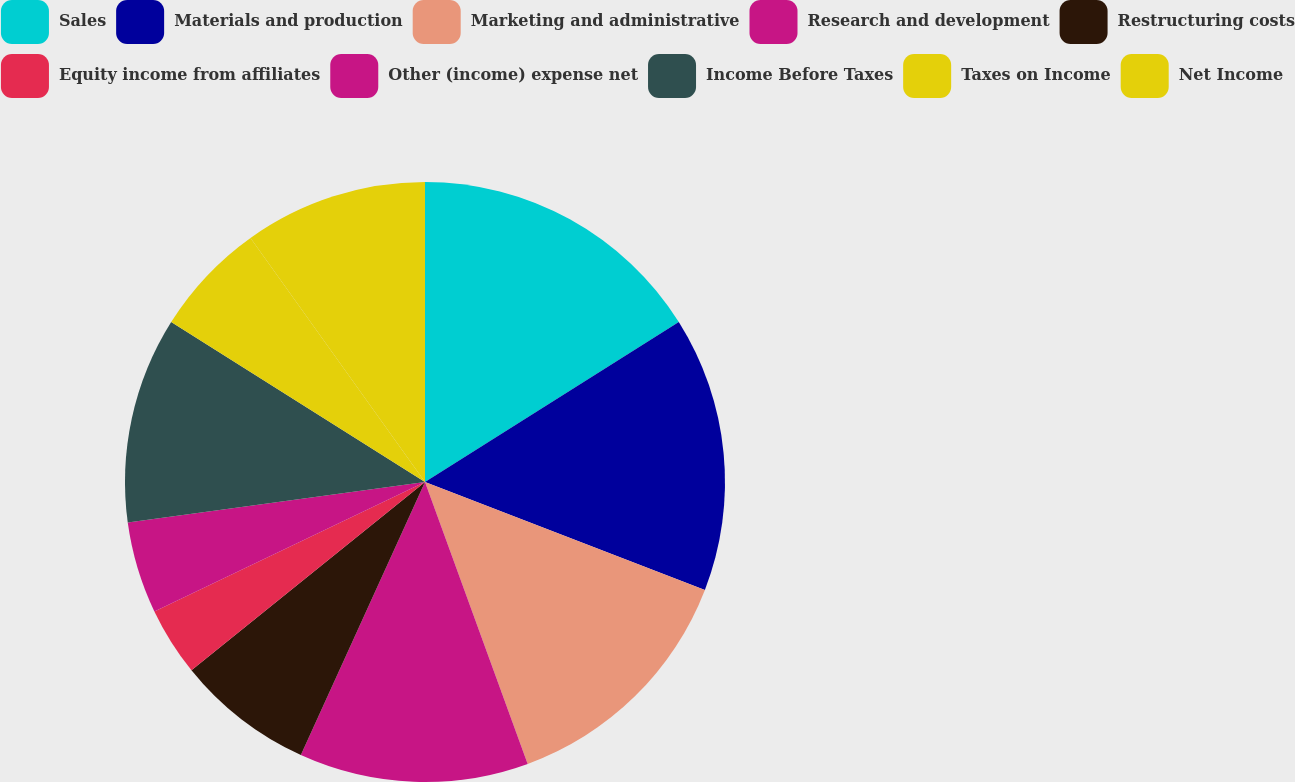Convert chart. <chart><loc_0><loc_0><loc_500><loc_500><pie_chart><fcel>Sales<fcel>Materials and production<fcel>Marketing and administrative<fcel>Research and development<fcel>Restructuring costs<fcel>Equity income from affiliates<fcel>Other (income) expense net<fcel>Income Before Taxes<fcel>Taxes on Income<fcel>Net Income<nl><fcel>16.05%<fcel>14.81%<fcel>13.58%<fcel>12.35%<fcel>7.41%<fcel>3.7%<fcel>4.94%<fcel>11.11%<fcel>6.17%<fcel>9.88%<nl></chart> 